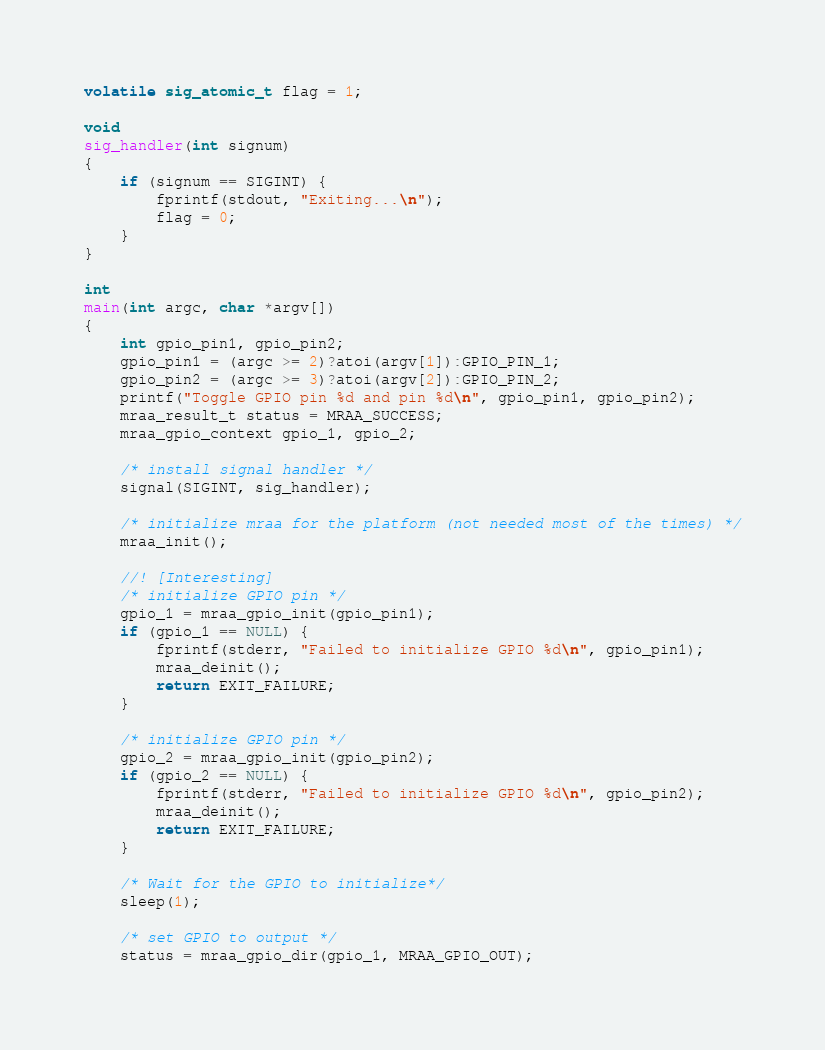Convert code to text. <code><loc_0><loc_0><loc_500><loc_500><_C_>
volatile sig_atomic_t flag = 1;

void
sig_handler(int signum)
{
    if (signum == SIGINT) {
        fprintf(stdout, "Exiting...\n");
        flag = 0;
    }
}

int
main(int argc, char *argv[])
{
    int gpio_pin1, gpio_pin2;
    gpio_pin1 = (argc >= 2)?atoi(argv[1]):GPIO_PIN_1;
    gpio_pin2 = (argc >= 3)?atoi(argv[2]):GPIO_PIN_2;
    printf("Toggle GPIO pin %d and pin %d\n", gpio_pin1, gpio_pin2);
    mraa_result_t status = MRAA_SUCCESS;
    mraa_gpio_context gpio_1, gpio_2;

    /* install signal handler */
    signal(SIGINT, sig_handler);

    /* initialize mraa for the platform (not needed most of the times) */
    mraa_init();

    //! [Interesting]
    /* initialize GPIO pin */
    gpio_1 = mraa_gpio_init(gpio_pin1);
    if (gpio_1 == NULL) {
        fprintf(stderr, "Failed to initialize GPIO %d\n", gpio_pin1);
        mraa_deinit();
        return EXIT_FAILURE;
    }

    /* initialize GPIO pin */
    gpio_2 = mraa_gpio_init(gpio_pin2);
    if (gpio_2 == NULL) {
        fprintf(stderr, "Failed to initialize GPIO %d\n", gpio_pin2);
        mraa_deinit();
        return EXIT_FAILURE;
    }

    /* Wait for the GPIO to initialize*/
    sleep(1);

    /* set GPIO to output */
    status = mraa_gpio_dir(gpio_1, MRAA_GPIO_OUT);</code> 